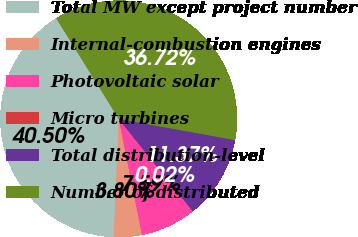Convert chart to OTSL. <chart><loc_0><loc_0><loc_500><loc_500><pie_chart><fcel>Total MW except project number<fcel>Internal-combustion engines<fcel>Photovoltaic solar<fcel>Micro turbines<fcel>Total distribution-level<fcel>Number of distributed<nl><fcel>40.5%<fcel>3.8%<fcel>7.59%<fcel>0.02%<fcel>11.37%<fcel>36.72%<nl></chart> 